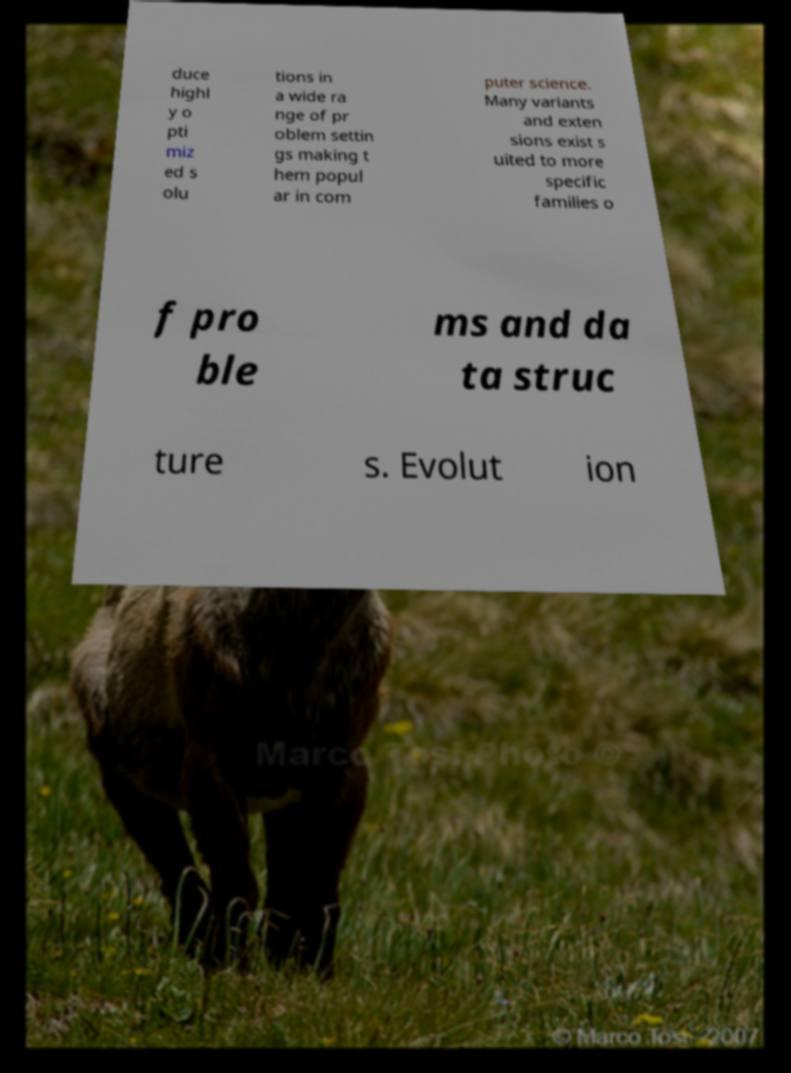What messages or text are displayed in this image? I need them in a readable, typed format. duce highl y o pti miz ed s olu tions in a wide ra nge of pr oblem settin gs making t hem popul ar in com puter science. Many variants and exten sions exist s uited to more specific families o f pro ble ms and da ta struc ture s. Evolut ion 